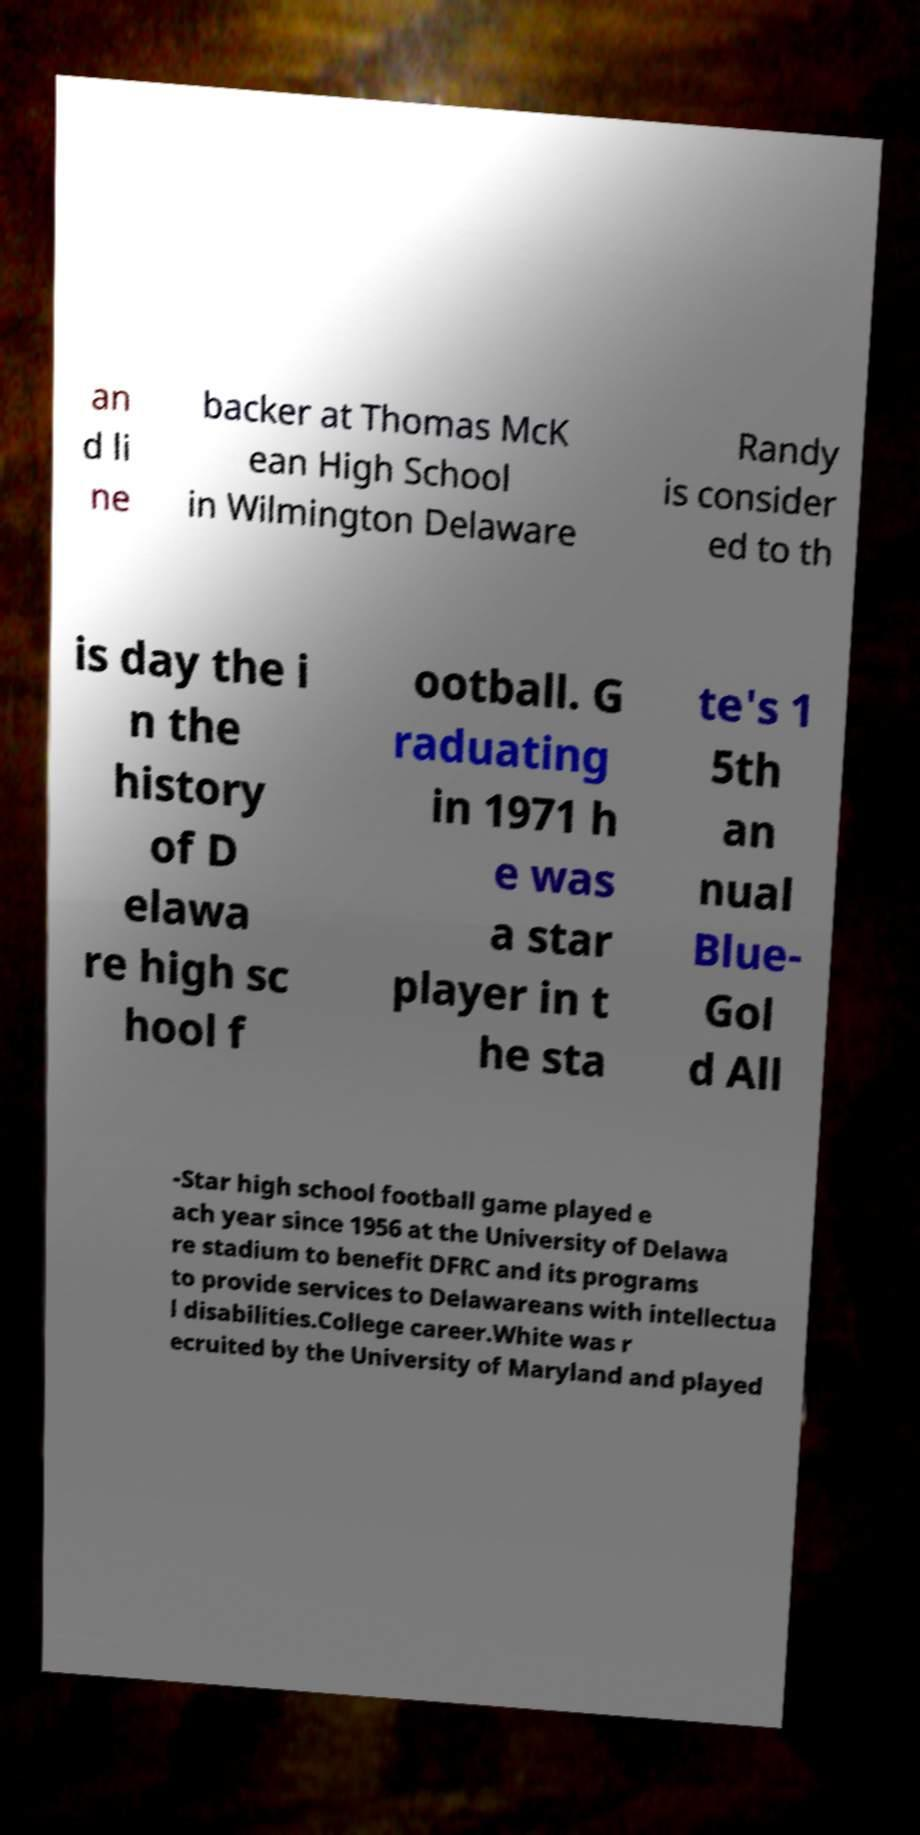Please read and relay the text visible in this image. What does it say? an d li ne backer at Thomas McK ean High School in Wilmington Delaware Randy is consider ed to th is day the i n the history of D elawa re high sc hool f ootball. G raduating in 1971 h e was a star player in t he sta te's 1 5th an nual Blue- Gol d All -Star high school football game played e ach year since 1956 at the University of Delawa re stadium to benefit DFRC and its programs to provide services to Delawareans with intellectua l disabilities.College career.White was r ecruited by the University of Maryland and played 